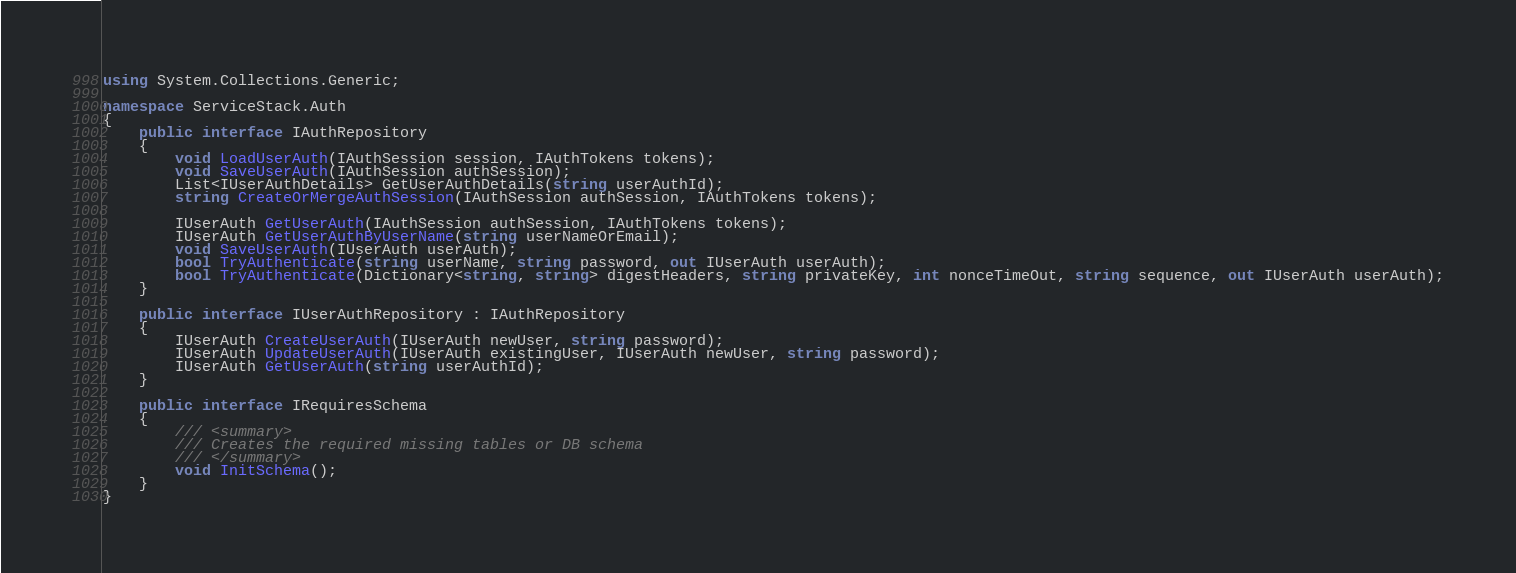<code> <loc_0><loc_0><loc_500><loc_500><_C#_>using System.Collections.Generic;

namespace ServiceStack.Auth
{
    public interface IAuthRepository
    {
        void LoadUserAuth(IAuthSession session, IAuthTokens tokens);
        void SaveUserAuth(IAuthSession authSession);
        List<IUserAuthDetails> GetUserAuthDetails(string userAuthId);
        string CreateOrMergeAuthSession(IAuthSession authSession, IAuthTokens tokens);

        IUserAuth GetUserAuth(IAuthSession authSession, IAuthTokens tokens);
        IUserAuth GetUserAuthByUserName(string userNameOrEmail);
        void SaveUserAuth(IUserAuth userAuth);
        bool TryAuthenticate(string userName, string password, out IUserAuth userAuth);
        bool TryAuthenticate(Dictionary<string, string> digestHeaders, string privateKey, int nonceTimeOut, string sequence, out IUserAuth userAuth);
    }

    public interface IUserAuthRepository : IAuthRepository
    {
        IUserAuth CreateUserAuth(IUserAuth newUser, string password);
        IUserAuth UpdateUserAuth(IUserAuth existingUser, IUserAuth newUser, string password);
        IUserAuth GetUserAuth(string userAuthId);
    }

    public interface IRequiresSchema
    {
        /// <summary>
        /// Creates the required missing tables or DB schema 
        /// </summary>
        void InitSchema();
    }
}</code> 